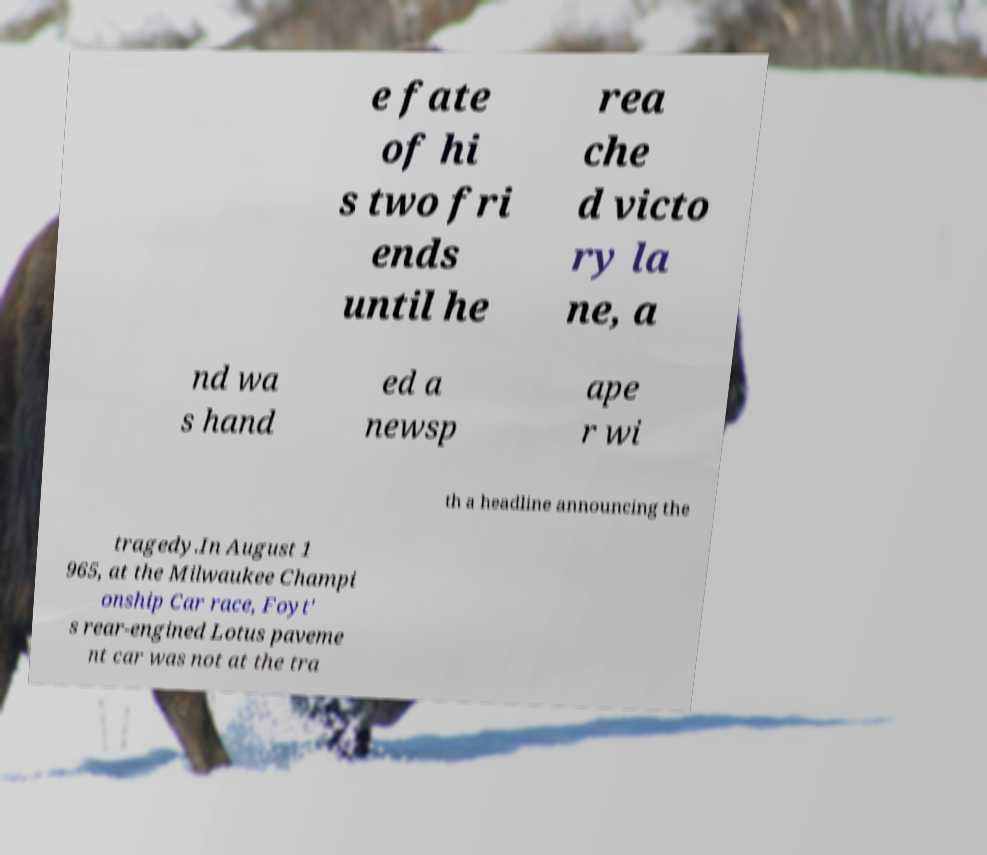Could you extract and type out the text from this image? e fate of hi s two fri ends until he rea che d victo ry la ne, a nd wa s hand ed a newsp ape r wi th a headline announcing the tragedy.In August 1 965, at the Milwaukee Champi onship Car race, Foyt' s rear-engined Lotus paveme nt car was not at the tra 